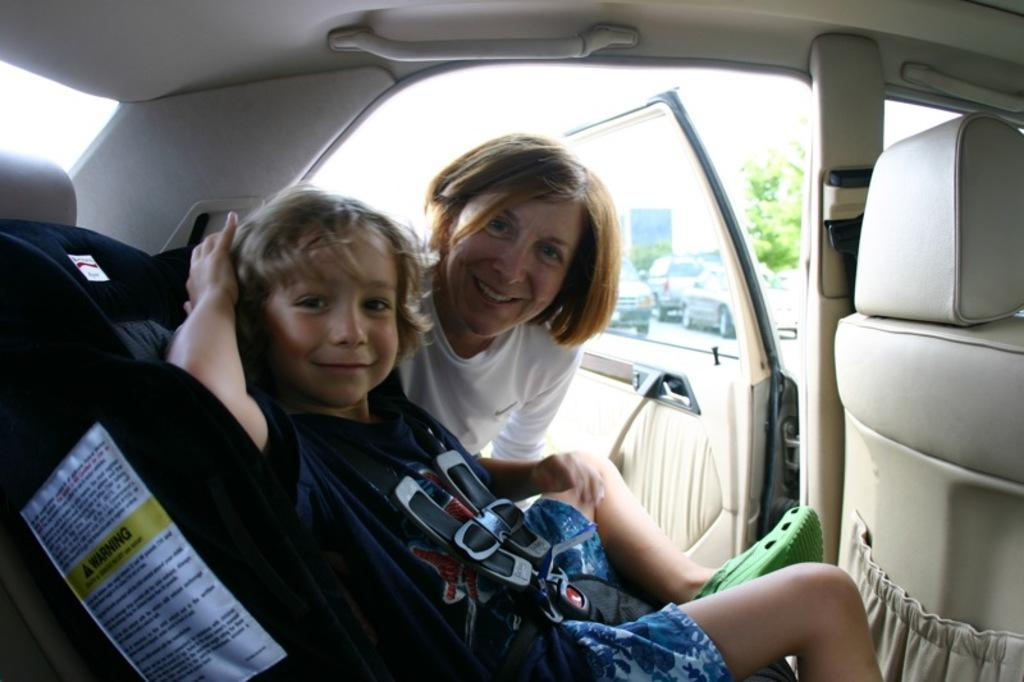What is the girl in the image doing? There is a girl sitting in a car, and another girl standing outside the car. What is the main object in the image? The main object in the image is a car. What can be seen in the background of the image? There is a tree visible in the image. What is the boy saying to the girl in the car? There is no boy present in the image, so it is not possible to answer that question. 